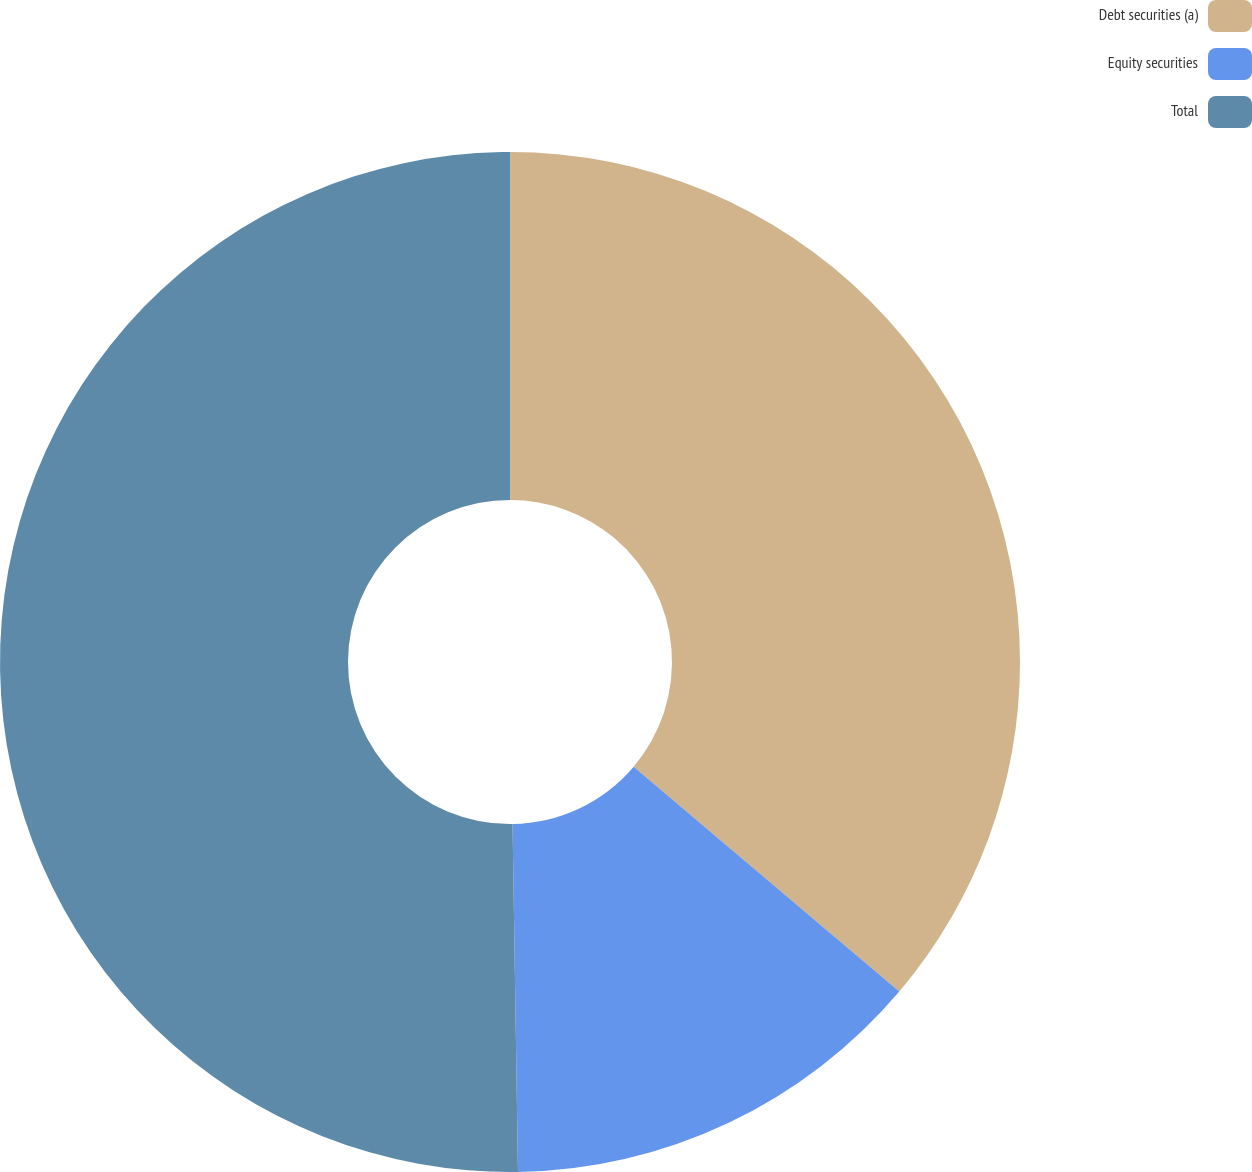Convert chart. <chart><loc_0><loc_0><loc_500><loc_500><pie_chart><fcel>Debt securities (a)<fcel>Equity securities<fcel>Total<nl><fcel>36.18%<fcel>13.57%<fcel>50.25%<nl></chart> 